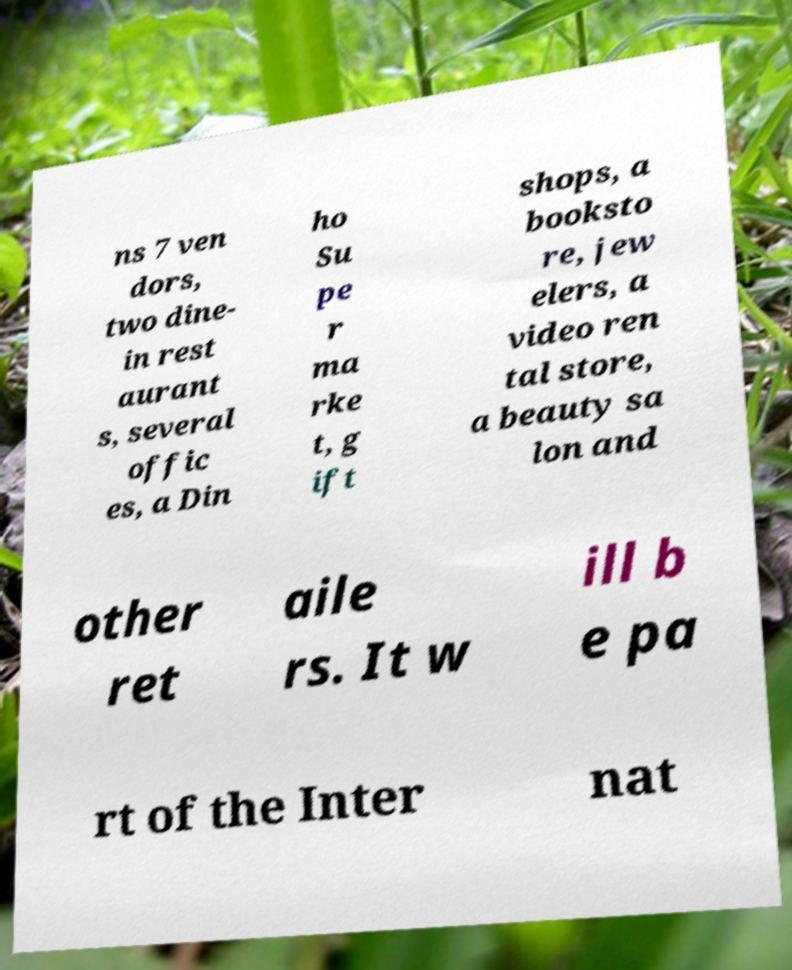Please identify and transcribe the text found in this image. ns 7 ven dors, two dine- in rest aurant s, several offic es, a Din ho Su pe r ma rke t, g ift shops, a booksto re, jew elers, a video ren tal store, a beauty sa lon and other ret aile rs. It w ill b e pa rt of the Inter nat 